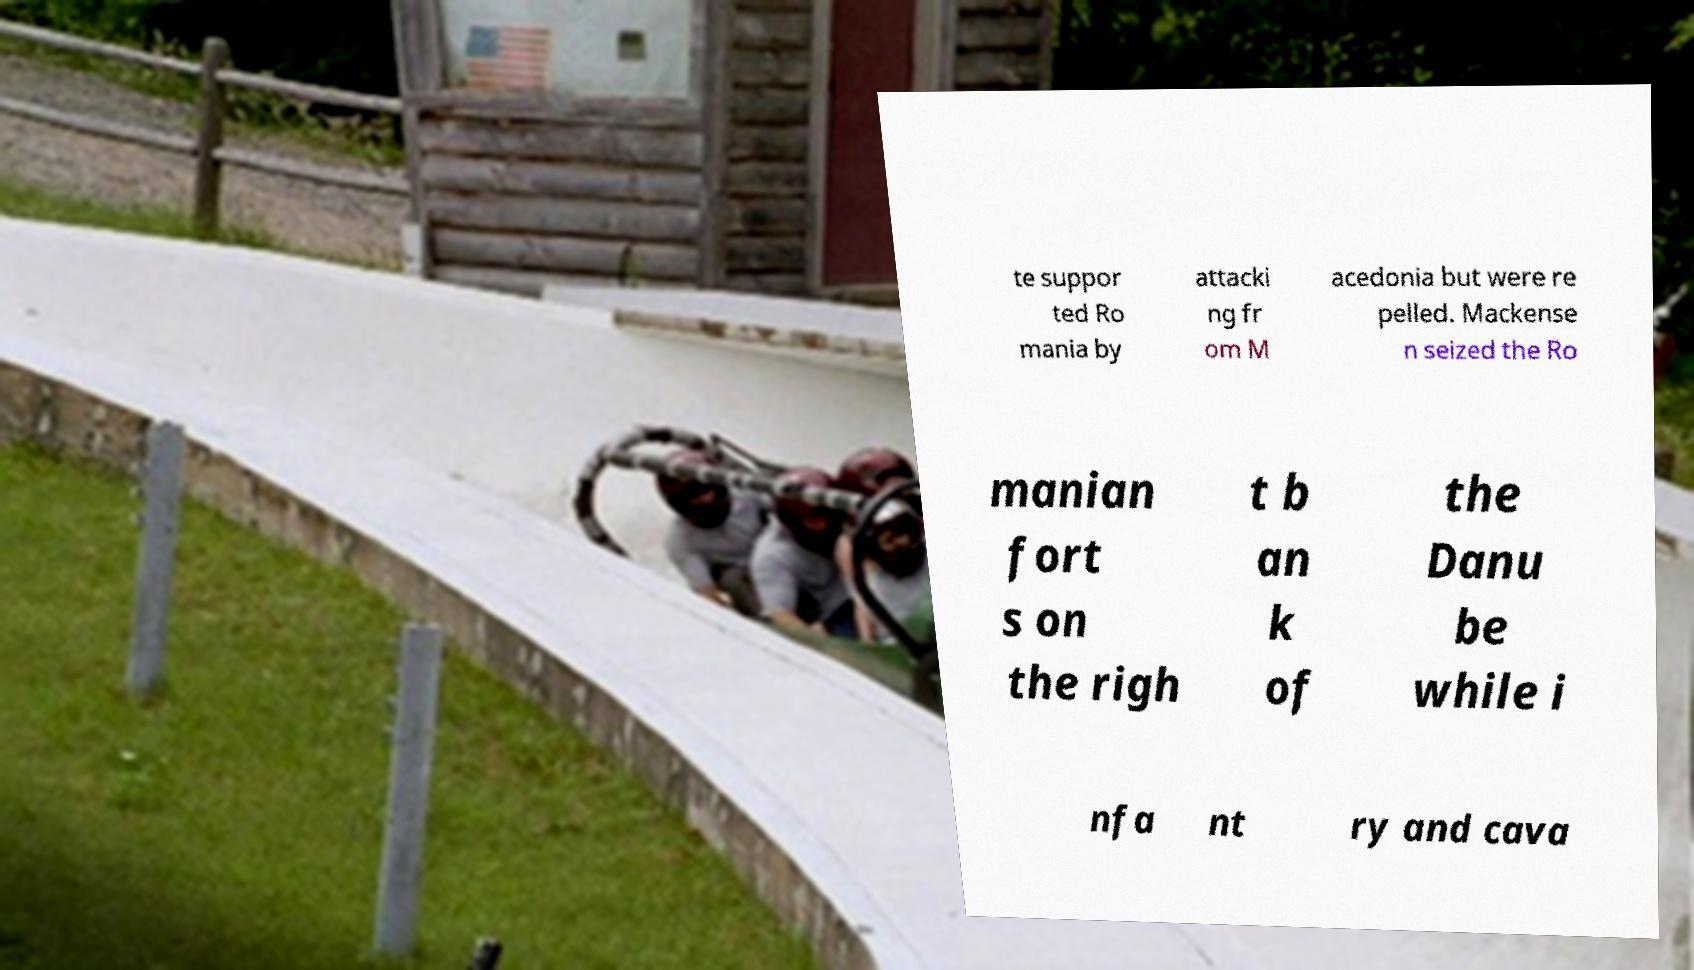I need the written content from this picture converted into text. Can you do that? te suppor ted Ro mania by attacki ng fr om M acedonia but were re pelled. Mackense n seized the Ro manian fort s on the righ t b an k of the Danu be while i nfa nt ry and cava 